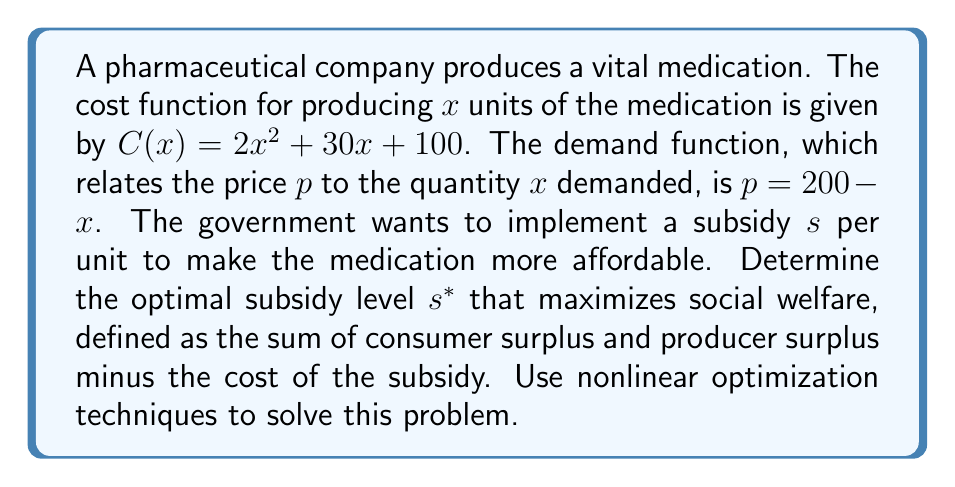Can you solve this math problem? 1) First, let's define the social welfare function (SW):
   $$ SW = CS + PS - \text{Subsidy Cost} $$

2) Consumer Surplus (CS):
   $$ CS = \int_{0}^{x} (200 - t) dt - (200 - x - s)x $$
   $$ CS = [200t - \frac{t^2}{2}]_{0}^{x} - (200 - x - s)x $$
   $$ CS = 200x - \frac{x^2}{2} - 200x + x^2 + sx $$
   $$ CS = \frac{x^2}{2} + sx $$

3) Producer Surplus (PS):
   $$ PS = (200 - x - s)x - (2x^2 + 30x + 100) $$
   $$ PS = 200x - x^2 - sx - 2x^2 - 30x - 100 $$
   $$ PS = 170x - 3x^2 - sx - 100 $$

4) Subsidy Cost:
   $$ \text{Subsidy Cost} = sx $$

5) Combining these into the Social Welfare function:
   $$ SW = (\frac{x^2}{2} + sx) + (170x - 3x^2 - sx - 100) - sx $$
   $$ SW = 170x - \frac{5x^2}{2} - 100 $$

6) To find the optimal quantity $x^*$, we differentiate SW with respect to x and set it to zero:
   $$ \frac{dSW}{dx} = 170 - 5x = 0 $$
   $$ x^* = 34 $$

7) Now, we need to find the subsidy $s^*$ that will result in this optimal quantity. We use the demand function and the firm's profit maximization condition:
   $$ p = 200 - x = 200 - 34 = 166 $$
   $$ MR = MC $$
   $$ 166 - s = 4x + 30 $$
   $$ 166 - s = 4(34) + 30 $$
   $$ 166 - s = 166 $$
   $$ s^* = 0 $$
Answer: $s^* = 0$ 